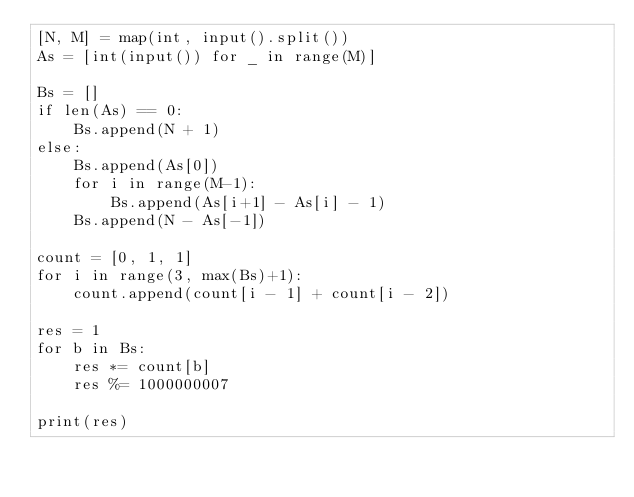Convert code to text. <code><loc_0><loc_0><loc_500><loc_500><_Python_>[N, M] = map(int, input().split())
As = [int(input()) for _ in range(M)]

Bs = []
if len(As) == 0:
    Bs.append(N + 1)
else:
    Bs.append(As[0])
    for i in range(M-1):
        Bs.append(As[i+1] - As[i] - 1)
    Bs.append(N - As[-1])

count = [0, 1, 1]
for i in range(3, max(Bs)+1):
    count.append(count[i - 1] + count[i - 2])

res = 1
for b in Bs:
    res *= count[b]
    res %= 1000000007

print(res)
</code> 